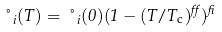<formula> <loc_0><loc_0><loc_500><loc_500>\nu _ { i } ( T ) = \nu _ { i } ( 0 ) ( 1 - ( T / T _ { \mathrm c } ) ^ { \alpha } ) ^ { \beta }</formula> 